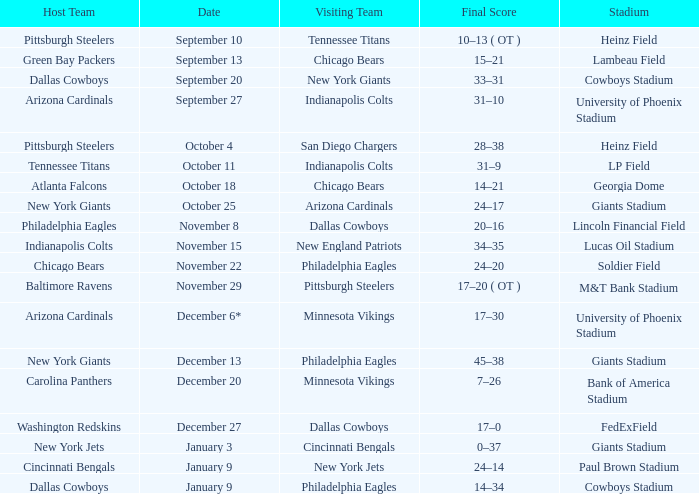Tell me the host team for giants stadium and visiting of cincinnati bengals New York Jets. 